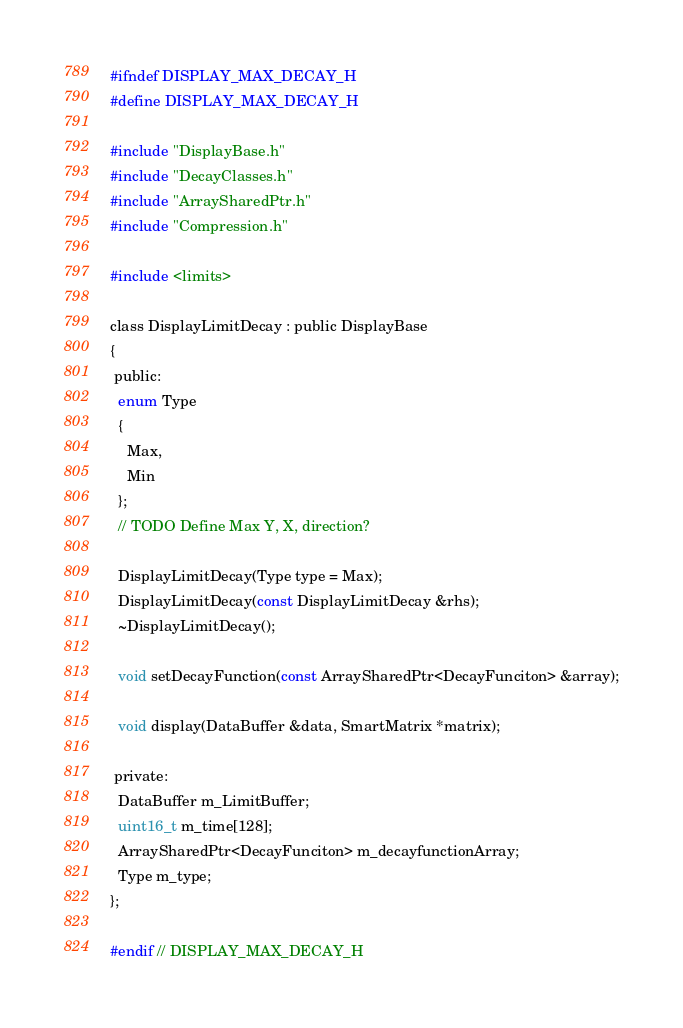<code> <loc_0><loc_0><loc_500><loc_500><_C_>#ifndef DISPLAY_MAX_DECAY_H
#define DISPLAY_MAX_DECAY_H

#include "DisplayBase.h"
#include "DecayClasses.h"
#include "ArraySharedPtr.h"
#include "Compression.h"

#include <limits>

class DisplayLimitDecay : public DisplayBase
{
 public:
  enum Type
  {
    Max,
    Min
  };
  // TODO Define Max Y, X, direction?
  
  DisplayLimitDecay(Type type = Max);
  DisplayLimitDecay(const DisplayLimitDecay &rhs);
  ~DisplayLimitDecay();
  
  void setDecayFunction(const ArraySharedPtr<DecayFunciton> &array);
  
  void display(DataBuffer &data, SmartMatrix *matrix);

 private:
  DataBuffer m_LimitBuffer;
  uint16_t m_time[128];
  ArraySharedPtr<DecayFunciton> m_decayfunctionArray;
  Type m_type;
};

#endif // DISPLAY_MAX_DECAY_H
</code> 